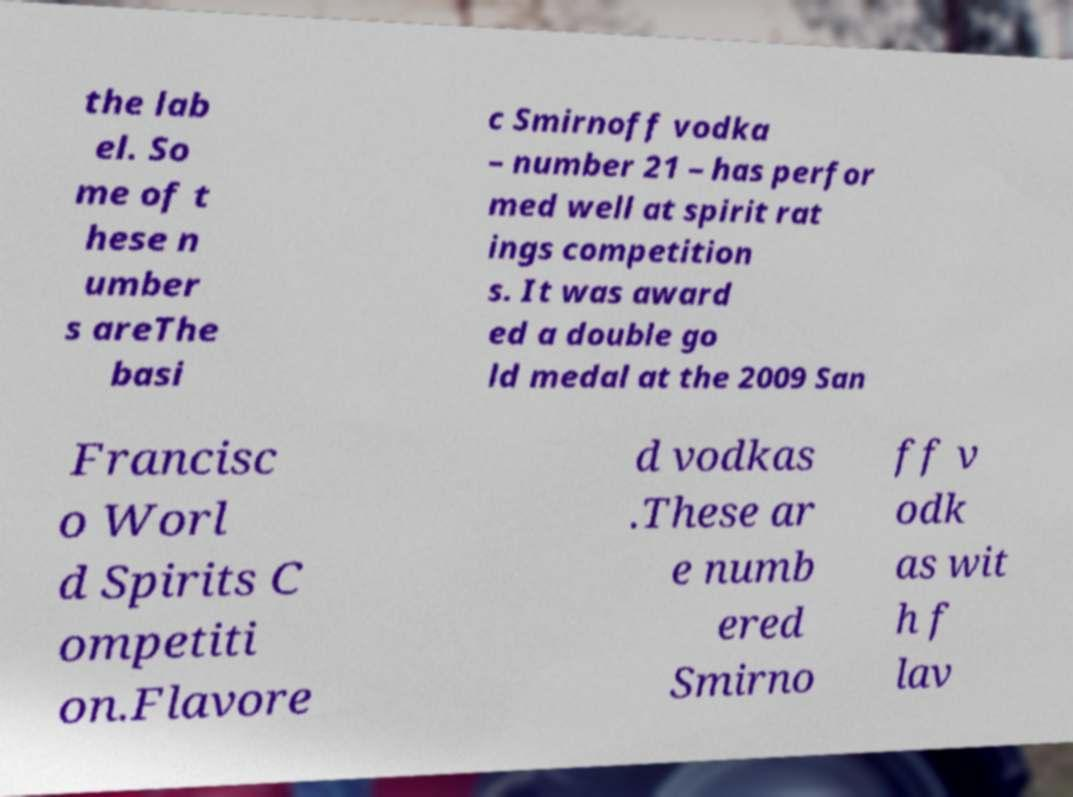There's text embedded in this image that I need extracted. Can you transcribe it verbatim? the lab el. So me of t hese n umber s areThe basi c Smirnoff vodka – number 21 – has perfor med well at spirit rat ings competition s. It was award ed a double go ld medal at the 2009 San Francisc o Worl d Spirits C ompetiti on.Flavore d vodkas .These ar e numb ered Smirno ff v odk as wit h f lav 